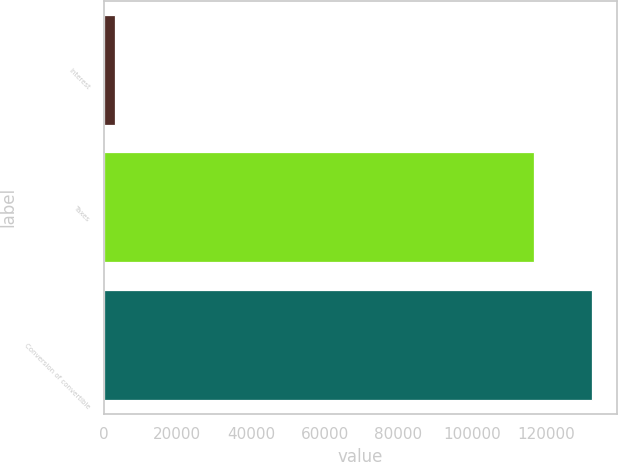Convert chart to OTSL. <chart><loc_0><loc_0><loc_500><loc_500><bar_chart><fcel>Interest<fcel>Taxes<fcel>Conversion of convertible<nl><fcel>2972<fcel>116733<fcel>132637<nl></chart> 